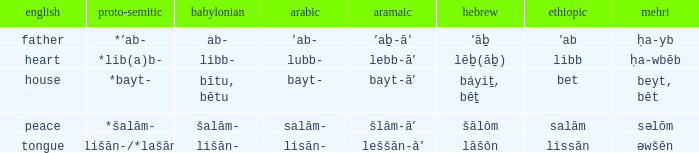If in English it's house, what is it in proto-semitic? *bayt-. Parse the table in full. {'header': ['english', 'proto-semitic', 'babylonian', 'arabic', 'aramaic', 'hebrew', 'ethiopic', 'mehri'], 'rows': [['father', '*ʼab-', 'ab-', 'ʼab-', 'ʼaḇ-āʼ', 'ʼāḇ', 'ʼab', 'ḥa-yb'], ['heart', '*lib(a)b-', 'libb-', 'lubb-', 'lebb-āʼ', 'lēḇ(āḇ)', 'libb', 'ḥa-wbēb'], ['house', '*bayt-', 'bītu, bētu', 'bayt-', 'bayt-āʼ', 'báyiṯ, bêṯ', 'bet', 'beyt, bêt'], ['peace', '*šalām-', 'šalām-', 'salām-', 'šlām-āʼ', 'šālôm', 'salām', 'səlōm'], ['tongue', '*lišān-/*lašān-', 'lišān-', 'lisān-', 'leššān-āʼ', 'lāšôn', 'lissān', 'əwšēn']]} 